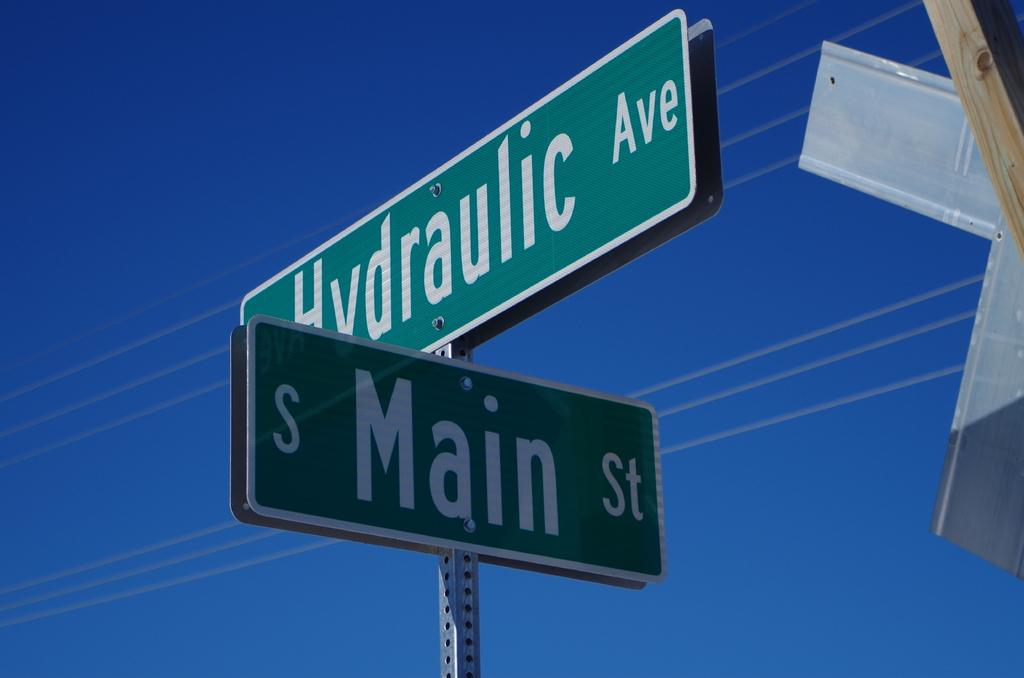<image>
Provide a brief description of the given image. An intersection street sign at Hydraulic Ave and S Main St. 